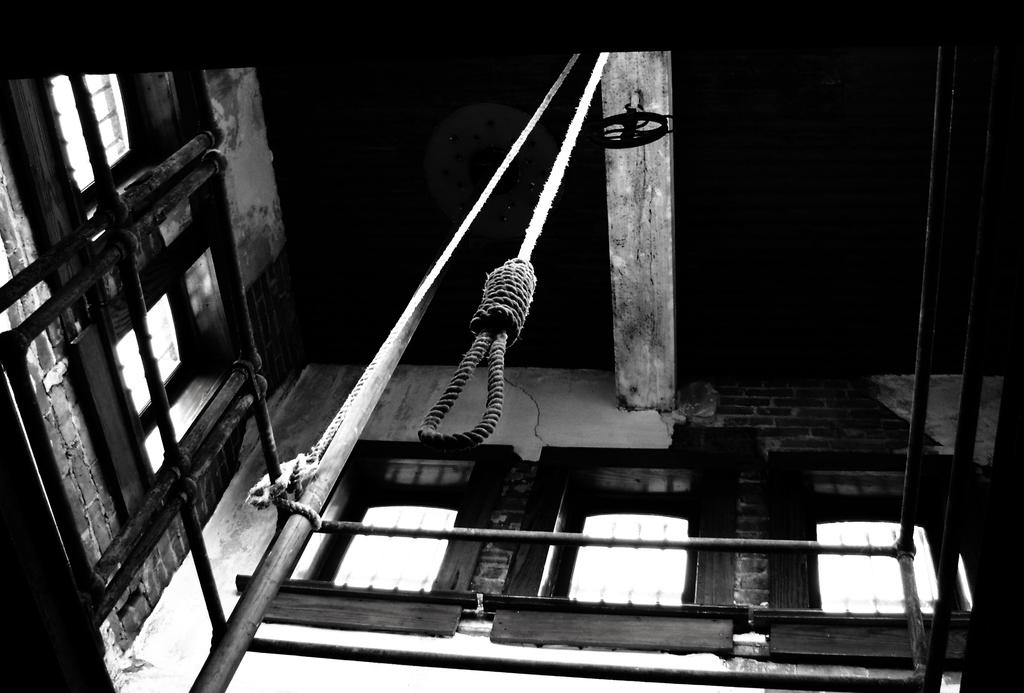What type of picture is in the image? The image contains a black and white picture. What objects can be seen in the picture? There is a metal rod, railing, and rope in the picture. Are there any architectural features visible in the picture? Yes, there are windows and a ceiling visible in the picture. What material are the walls made of? The walls are made of bricks. How many visitors can be seen in the image? There are no visitors present in the image; it only contains a picture with various objects and architectural features. What type of calendar is hanging on the wall in the image? There is no calendar present in the image. 